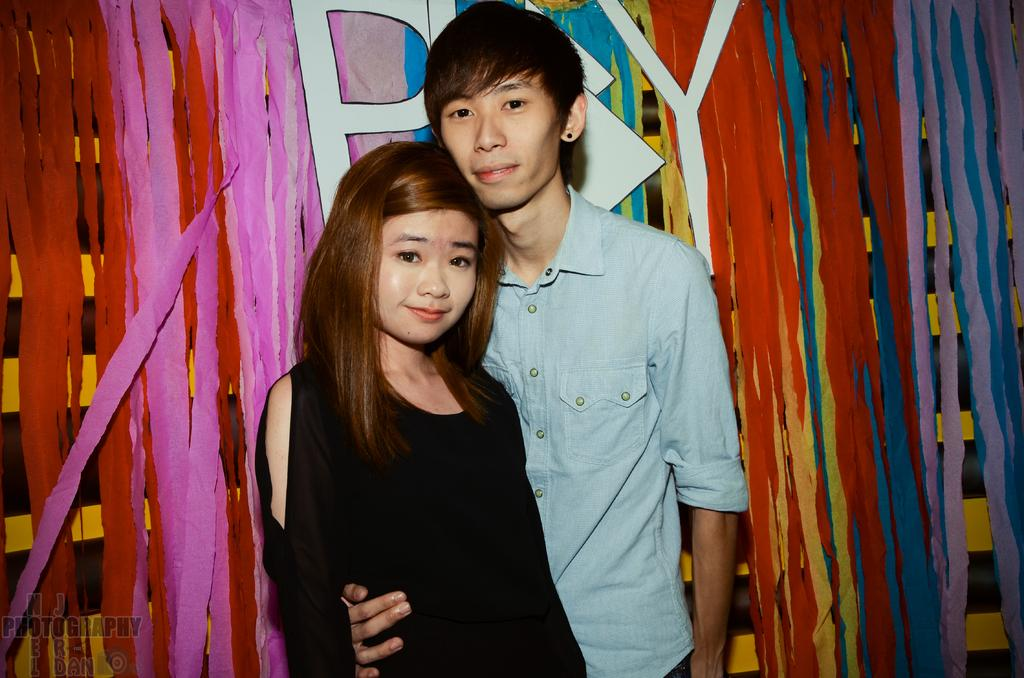How many people are present in the image? There is a man and a woman standing in the image. What can be seen in the background of the image? There is a board and paper ribbons in the background of the image. Is there any text or marking on the image? Yes, there is a watermark on the image. What type of balls are being used in the image? There are no balls present in the image. What does the insurance policy cover in the image? There is no mention of an insurance policy in the image. 